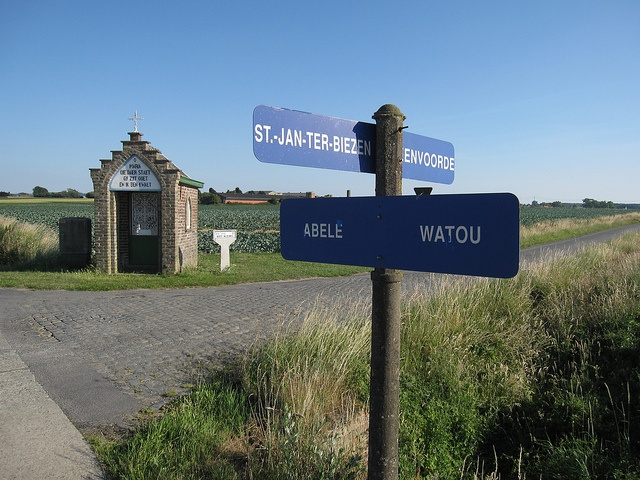Describe the objects in this image and their specific colors. I can see various objects in this image with different colors. 